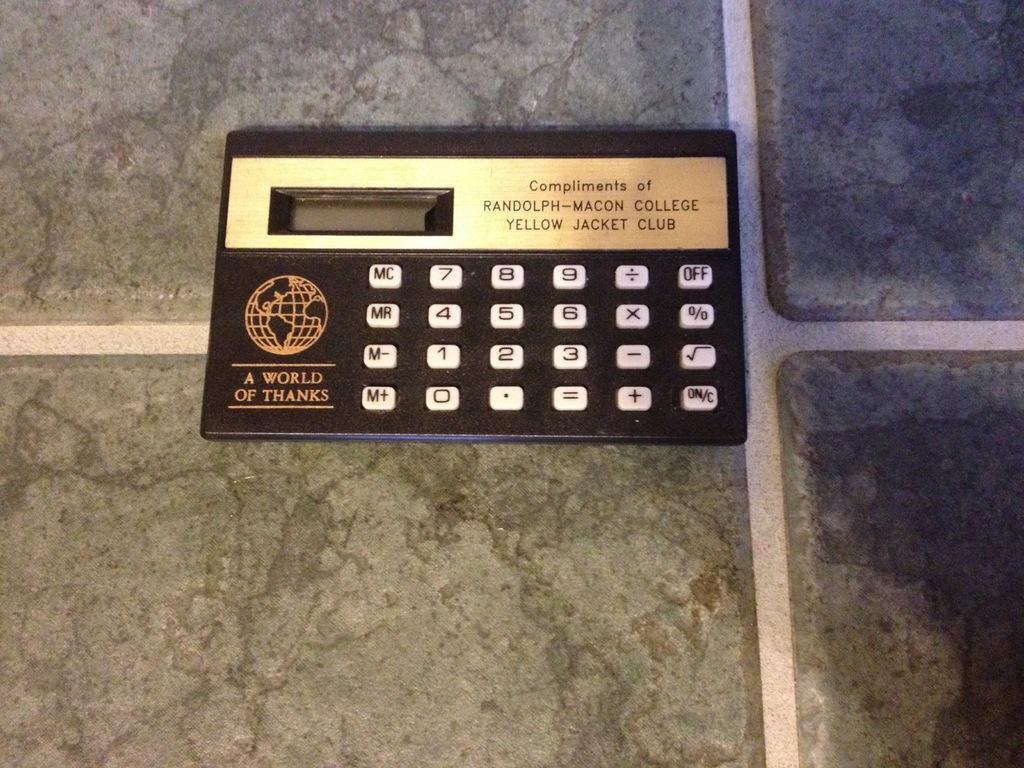Describe this image in one or two sentences. In the center of the image there is a calculator placed on the table. 